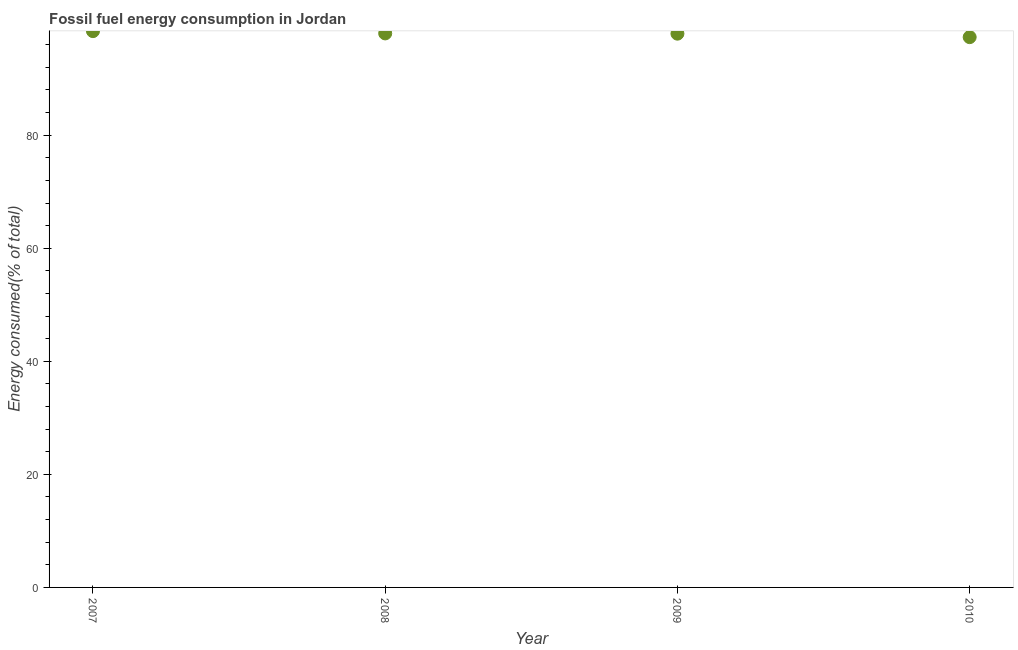What is the fossil fuel energy consumption in 2007?
Provide a short and direct response. 98.41. Across all years, what is the maximum fossil fuel energy consumption?
Your response must be concise. 98.41. Across all years, what is the minimum fossil fuel energy consumption?
Offer a terse response. 97.35. In which year was the fossil fuel energy consumption maximum?
Ensure brevity in your answer.  2007. In which year was the fossil fuel energy consumption minimum?
Provide a short and direct response. 2010. What is the sum of the fossil fuel energy consumption?
Provide a short and direct response. 391.72. What is the difference between the fossil fuel energy consumption in 2007 and 2010?
Give a very brief answer. 1.06. What is the average fossil fuel energy consumption per year?
Your answer should be compact. 97.93. What is the median fossil fuel energy consumption?
Keep it short and to the point. 97.98. What is the ratio of the fossil fuel energy consumption in 2008 to that in 2010?
Provide a succinct answer. 1.01. What is the difference between the highest and the second highest fossil fuel energy consumption?
Keep it short and to the point. 0.41. What is the difference between the highest and the lowest fossil fuel energy consumption?
Provide a short and direct response. 1.06. In how many years, is the fossil fuel energy consumption greater than the average fossil fuel energy consumption taken over all years?
Your answer should be very brief. 3. Does the fossil fuel energy consumption monotonically increase over the years?
Your answer should be compact. No. How many dotlines are there?
Your response must be concise. 1. Are the values on the major ticks of Y-axis written in scientific E-notation?
Offer a very short reply. No. Does the graph contain any zero values?
Your answer should be compact. No. What is the title of the graph?
Your answer should be compact. Fossil fuel energy consumption in Jordan. What is the label or title of the Y-axis?
Give a very brief answer. Energy consumed(% of total). What is the Energy consumed(% of total) in 2007?
Give a very brief answer. 98.41. What is the Energy consumed(% of total) in 2008?
Your response must be concise. 98. What is the Energy consumed(% of total) in 2009?
Provide a succinct answer. 97.96. What is the Energy consumed(% of total) in 2010?
Give a very brief answer. 97.35. What is the difference between the Energy consumed(% of total) in 2007 and 2008?
Keep it short and to the point. 0.41. What is the difference between the Energy consumed(% of total) in 2007 and 2009?
Offer a terse response. 0.45. What is the difference between the Energy consumed(% of total) in 2007 and 2010?
Give a very brief answer. 1.06. What is the difference between the Energy consumed(% of total) in 2008 and 2009?
Your answer should be very brief. 0.04. What is the difference between the Energy consumed(% of total) in 2008 and 2010?
Ensure brevity in your answer.  0.66. What is the difference between the Energy consumed(% of total) in 2009 and 2010?
Your answer should be compact. 0.61. What is the ratio of the Energy consumed(% of total) in 2007 to that in 2009?
Keep it short and to the point. 1. What is the ratio of the Energy consumed(% of total) in 2007 to that in 2010?
Provide a short and direct response. 1.01. What is the ratio of the Energy consumed(% of total) in 2008 to that in 2009?
Your answer should be compact. 1. 